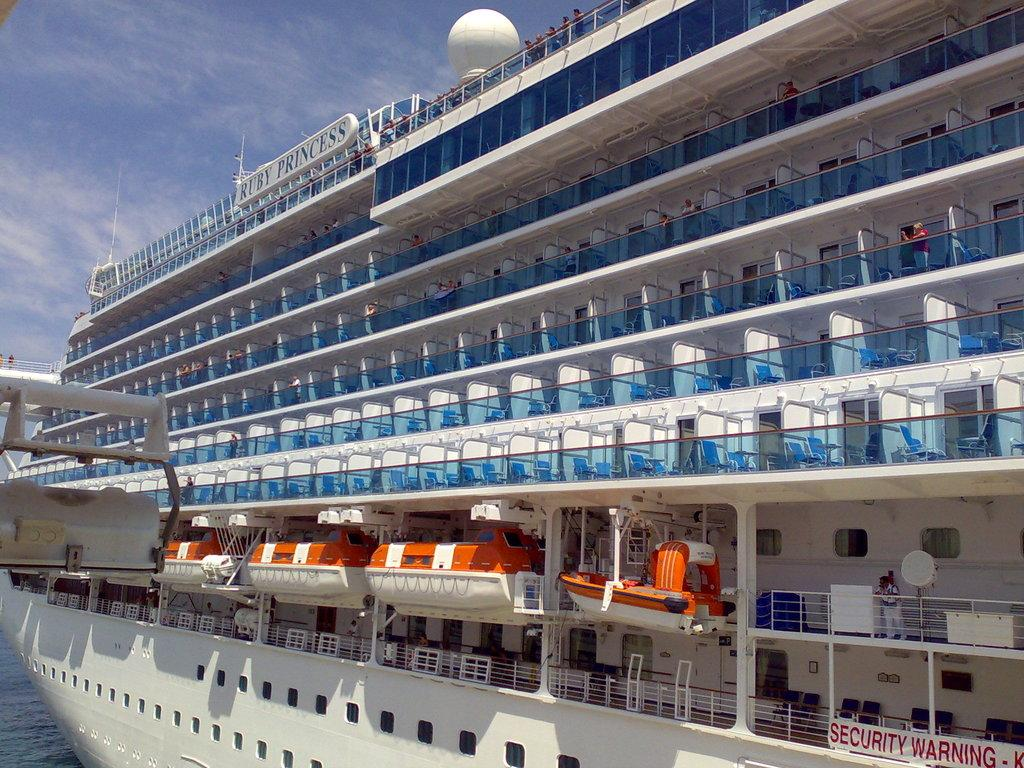What is the main subject of the image? The main subject of the image is a ship. How is the ship depicted in the image? The ship is truncated in the image. Where is the ship located? The ship is on the water in the image. What else can be seen in the image besides the ship? The sky is visible in the image, and there are clouds in the sky. How many girls are playing with the ship in the image? There are no girls present in the image; it features a ship on the water. What type of copy is being made of the ship in the image? There is no copying process depicted in the image; it simply shows a ship on the water. 